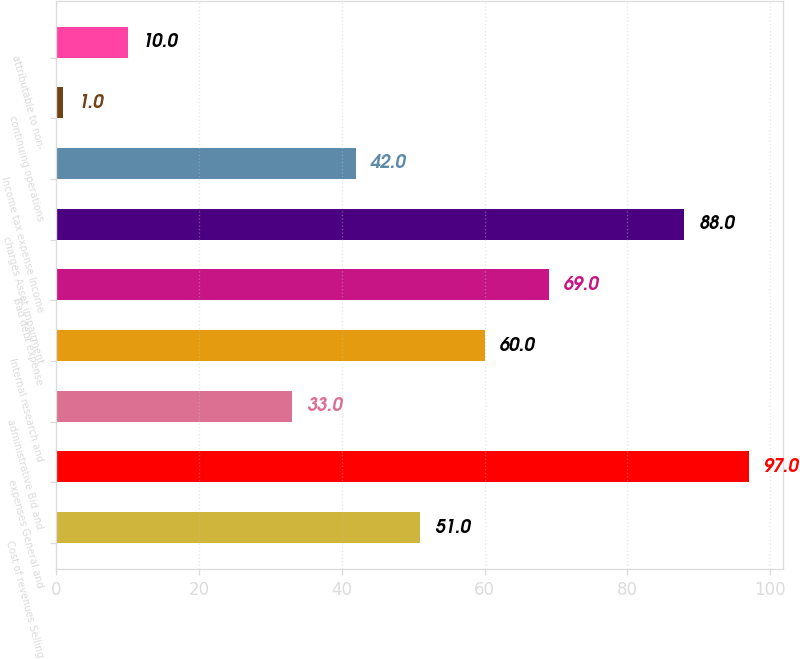Convert chart to OTSL. <chart><loc_0><loc_0><loc_500><loc_500><bar_chart><fcel>Cost of revenues Selling<fcel>expenses General and<fcel>administrative Bid and<fcel>Internal research and<fcel>Bad debt expense<fcel>charges Asset impairment<fcel>Income tax expense Income<fcel>continuing operations<fcel>attributable to non-<nl><fcel>51<fcel>97<fcel>33<fcel>60<fcel>69<fcel>88<fcel>42<fcel>1<fcel>10<nl></chart> 